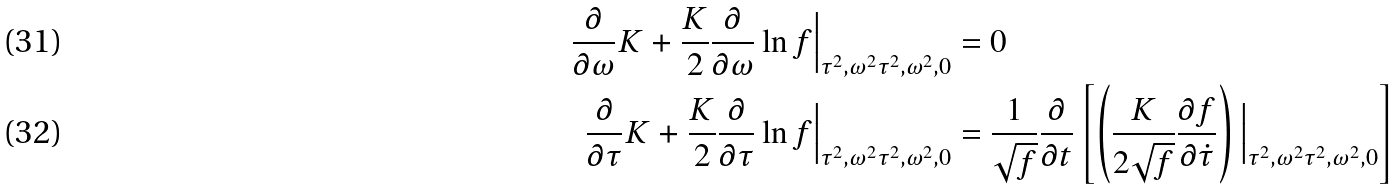<formula> <loc_0><loc_0><loc_500><loc_500>\frac { \partial } { \partial \omega } K + \frac { K } { 2 } \frac { \partial } { \partial \omega } \ln f \Big | _ { \tau ^ { 2 } , \omega ^ { 2 } \tau ^ { 2 } , \omega ^ { 2 } , 0 } & = 0 \\ \frac { \partial } { \partial \tau } K + \frac { K } { 2 } \frac { \partial } { \partial \tau } \ln f \Big | _ { \tau ^ { 2 } , \omega ^ { 2 } \tau ^ { 2 } , \omega ^ { 2 } , 0 } & = \frac { 1 } { \sqrt { f } } \frac { \partial } { \partial t } \left [ \left ( \frac { K } { 2 \sqrt { f } } \frac { \partial f } { \partial \dot { \tau } } \right ) \Big | _ { \tau ^ { 2 } , \omega ^ { 2 } \tau ^ { 2 } , \omega ^ { 2 } , 0 } \right ]</formula> 